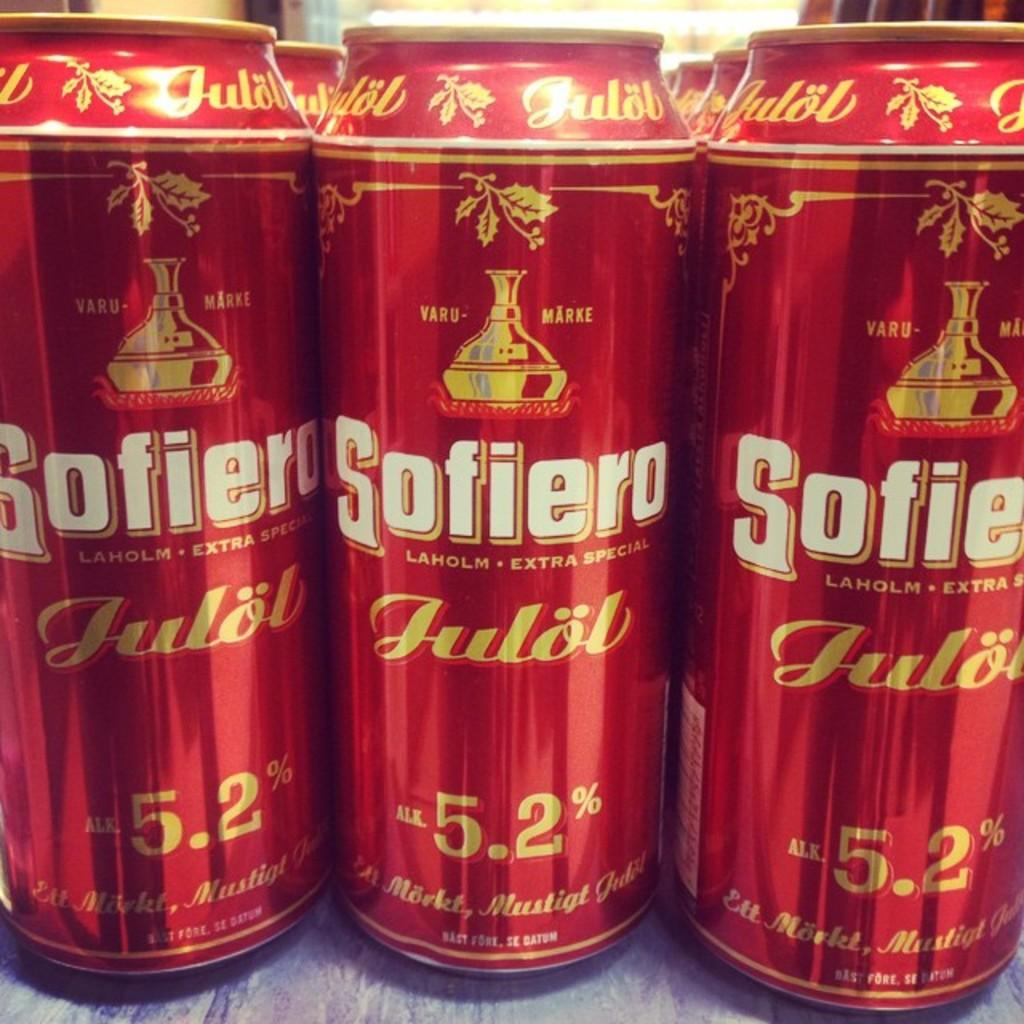What objects are present in the image? There are cans in the image. Can you describe the appearance of the cans? The cans are in dark red color. Are there any labels or markings on the cans? Yes, there are names on the cans. Can you tell me how many frogs are sitting on top of the cans in the image? There are no frogs present in the image; it only features cans with names on them. What type of farm equipment is depicted in the image? There is no farm equipment, such as a plough, present in the image. 